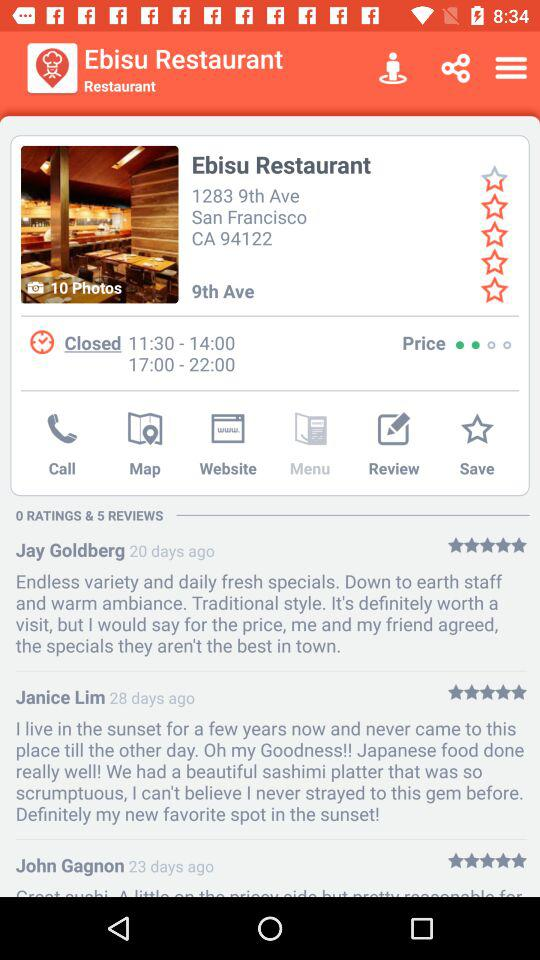How many photos in total are there of the "Ebisu Restaurant"? There are 10 photos in total of the "Ebisu Restaurant". 